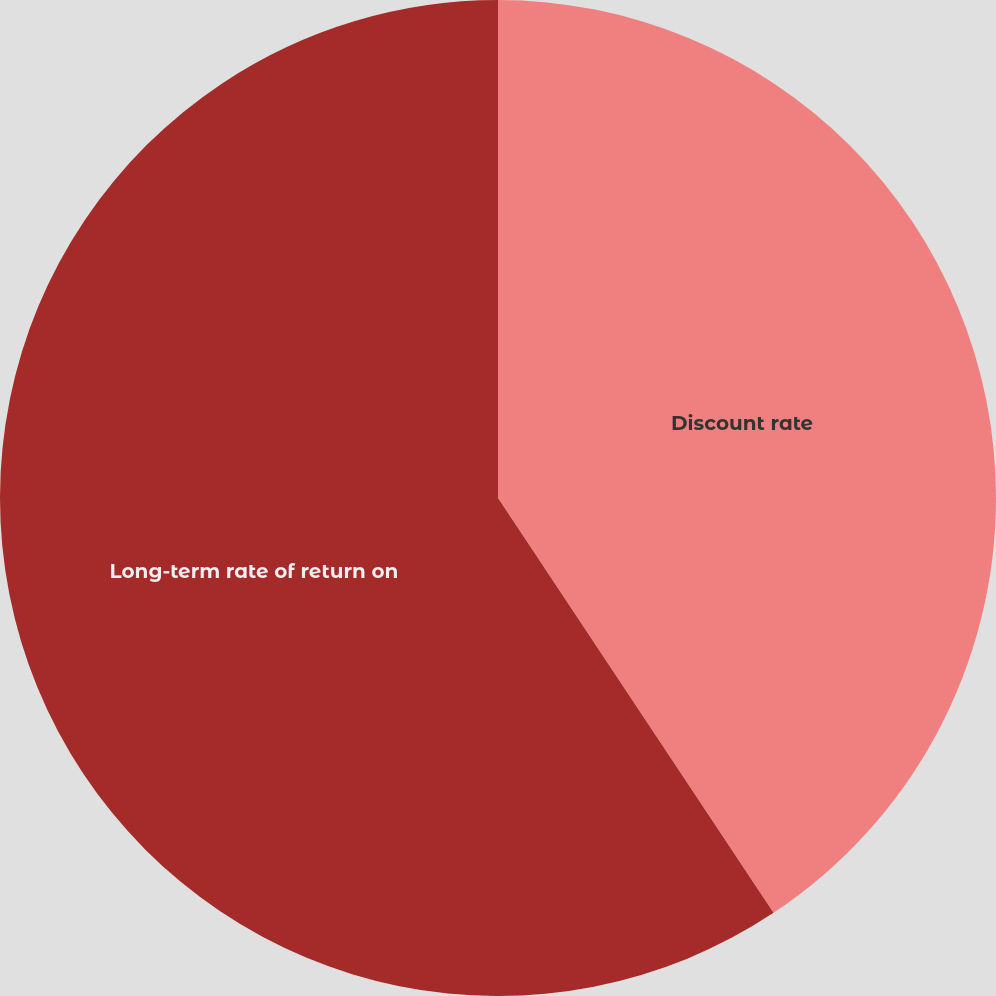<chart> <loc_0><loc_0><loc_500><loc_500><pie_chart><fcel>Discount rate<fcel>Long-term rate of return on<nl><fcel>40.67%<fcel>59.33%<nl></chart> 